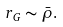<formula> <loc_0><loc_0><loc_500><loc_500>r _ { G } \sim \bar { \rho } .</formula> 